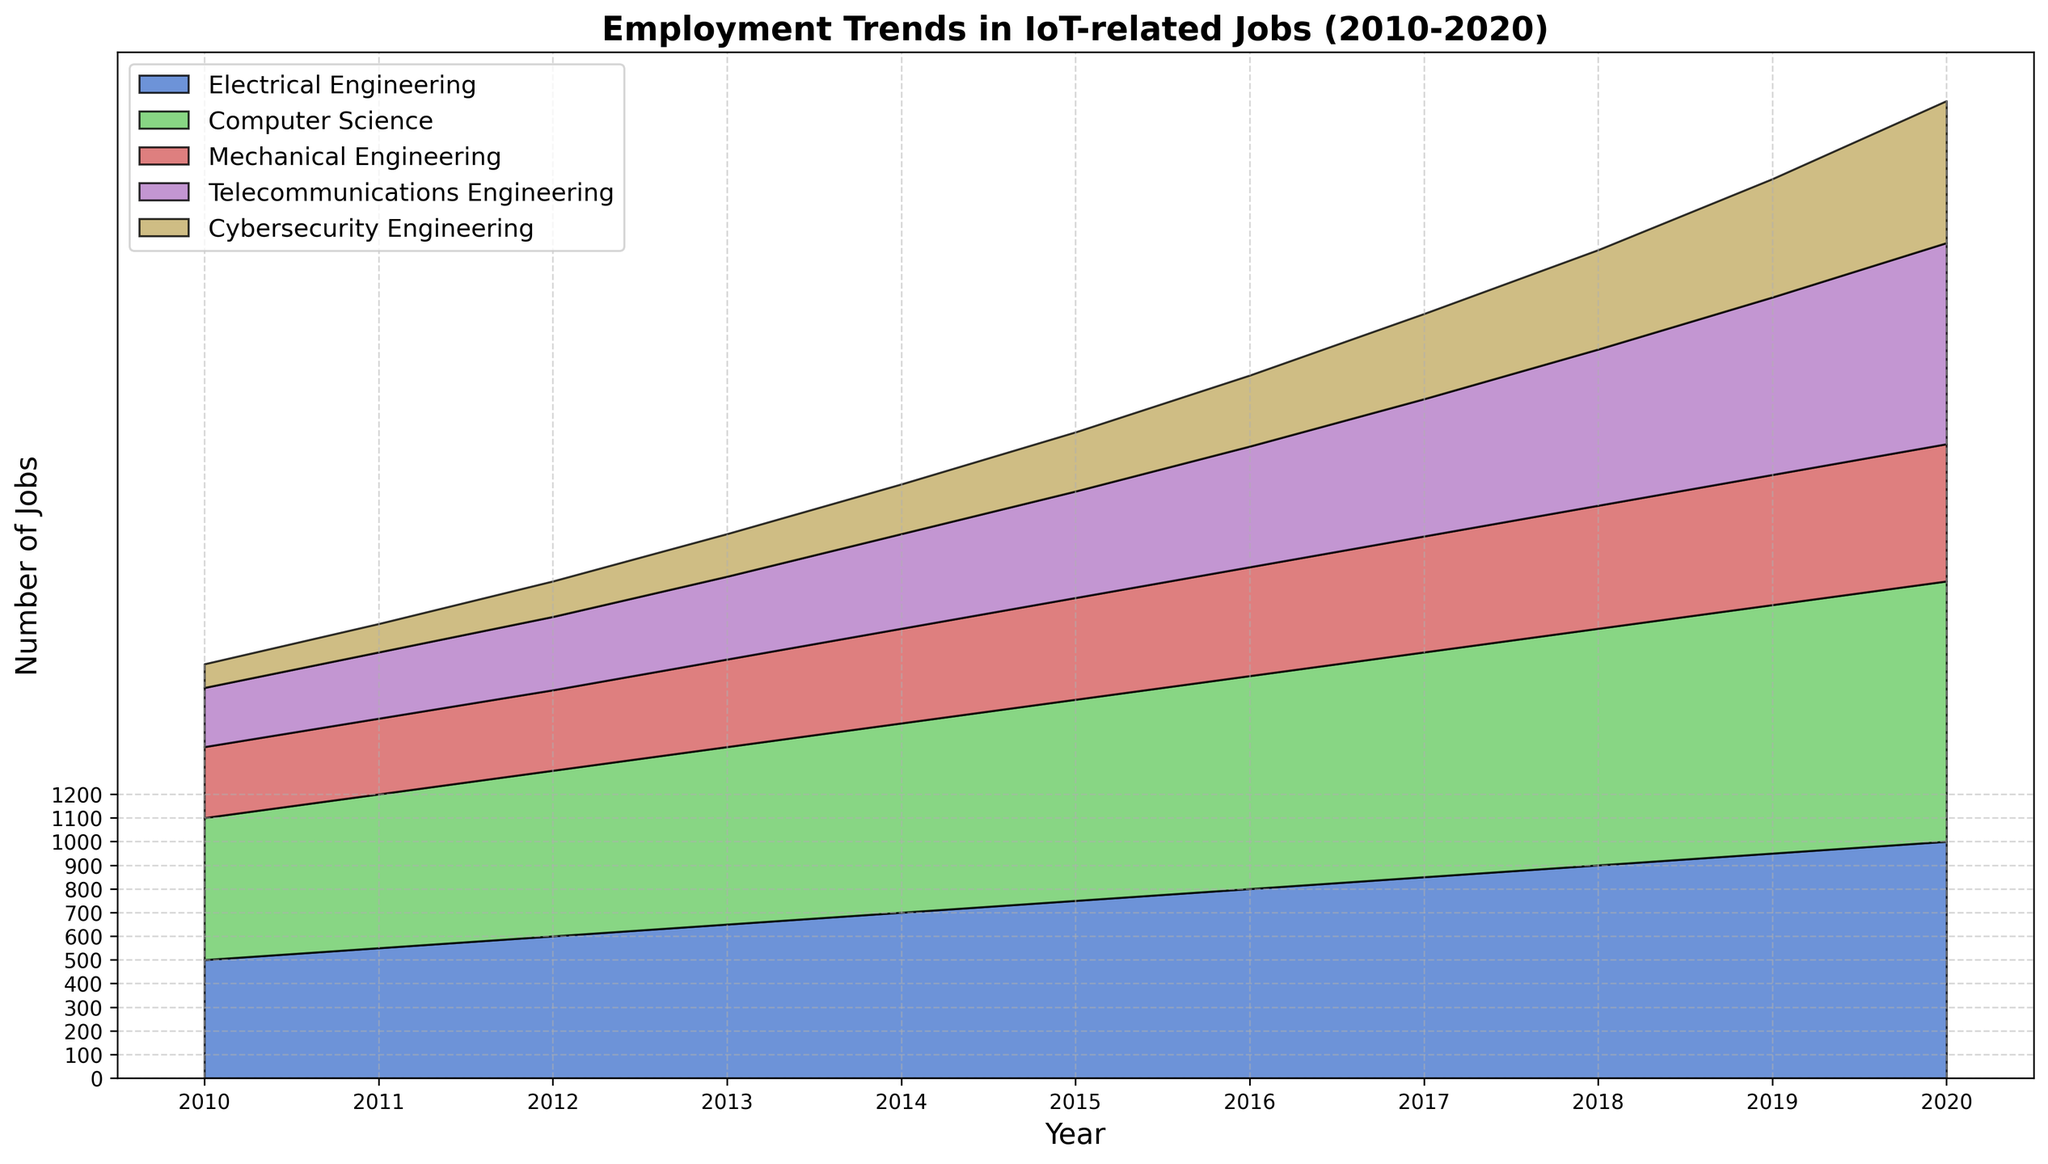What is the trend in the number of jobs for Electrical Engineering from 2010 to 2020? By observing the stacked area chart, we can see the increasing area attributed to Electrical Engineering across the years. This indicates a steady growth in job numbers from 500 in 2010 to 1000 in 2020.
Answer: Steady increase By how much did the number of Cybersecurity Engineering jobs increase from 2010 to 2020? The number of Cybersecurity Engineering jobs in 2010 was 100 and in 2020, it was 600. The increase can be calculated as 600 - 100 = 500 jobs.
Answer: 500 jobs Which year had the highest total number of IoT-related jobs across all disciplines? Sum the job numbers for each discipline for every year and find the highest sum. Max sum is found in 2020 (1000 + 1100 + 580 + 850 + 600 = 4130).
Answer: 2020 In 2015, which discipline had the lowest number of jobs? Look at the areas in 2015 and compare their heights. Cybersecurity Engineering had the smallest area, which indicates it had the lowest job count (250).
Answer: Cybersecurity Engineering How do the numbers of jobs in Computer Science and Telecommunications Engineering compare in 2018? For 2018, Computer Science has 1000 jobs, and Telecommunications Engineering has 660 jobs. Computer Science has more jobs.
Answer: Computer Science > Telecommunications Engineering What is the average number of IoT-related jobs for Mechanical Engineering from 2010 to 2020? Sum the values for Mechanical Engineering jobs from 2010 to 2020 (300+320+340+370+400+430+460+490+520+550+580 = 4760) and divide by the number of years (4760 / 11).
Answer: 432.7 jobs In which year did Electrical Engineering surpass 750 jobs for the first time? Trace the trend of Electrical Engineering jobs and check the year values. Electrical Engineering surpassed 750 jobs in 2015.
Answer: 2015 What is the growth rate in the number of jobs for Telecommunications Engineering between 2010 and 2020? Calculate the percentage increase from 2010 to 2020. ((850-250)/250) * 100 = 240%.
Answer: 240% Compare the job trends for Mechanical Engineering and Cybersecurity Engineering. What can you infer? Both show an increasing trend, but Cybersecurity Engineering has a steeper increase, starting from a lower base and surpassing Mechanical Engineering in 2020 (580 vs 600).
Answer: Cybersecurity grew faster Which discipline showed the highest growth rate from 2010 to 2020? Calculate the percentage increases for all disciplines from 2010 to 2020. Cybersecurity Engineering had the highest growth rate ((600-100)/100) * 100 = 500%.
Answer: Cybersecurity Engineering 